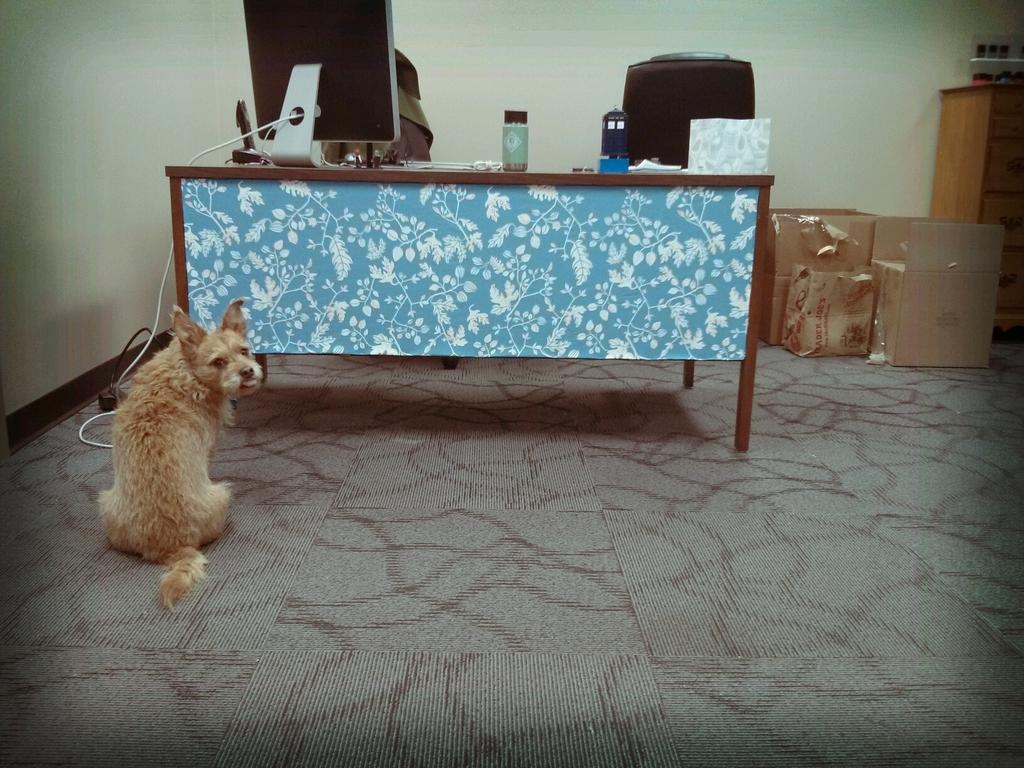How would you summarize this image in a sentence or two? We can see animal on the floor. There is a table. On the table we can see monitor,bottle. We can see chair. On the background we can see wall. This is cardboard. 